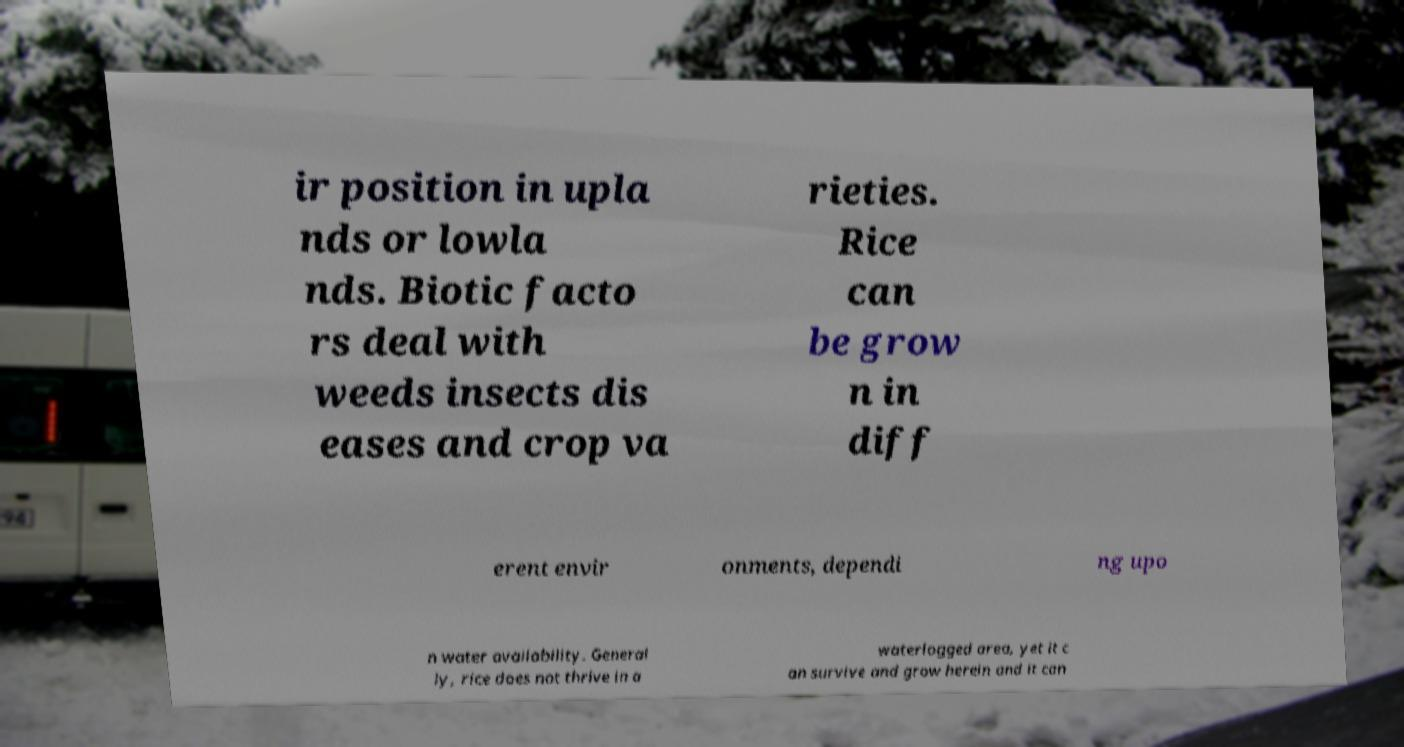There's text embedded in this image that I need extracted. Can you transcribe it verbatim? ir position in upla nds or lowla nds. Biotic facto rs deal with weeds insects dis eases and crop va rieties. Rice can be grow n in diff erent envir onments, dependi ng upo n water availability. General ly, rice does not thrive in a waterlogged area, yet it c an survive and grow herein and it can 